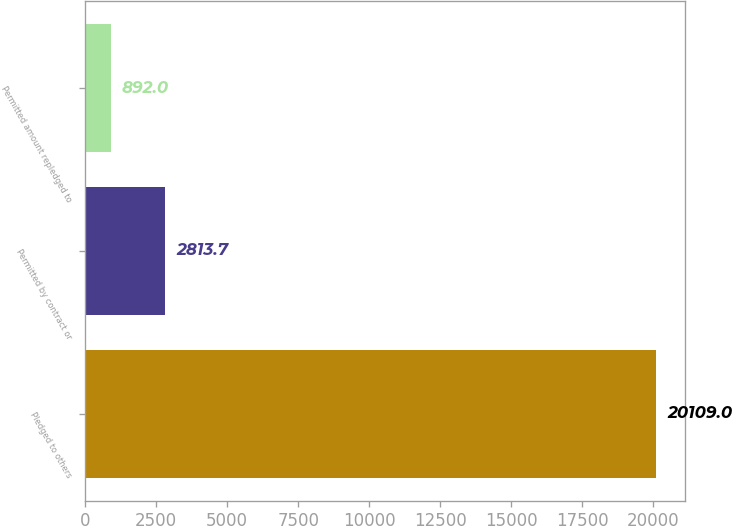Convert chart to OTSL. <chart><loc_0><loc_0><loc_500><loc_500><bar_chart><fcel>Pledged to others<fcel>Permitted by contract or<fcel>Permitted amount repledged to<nl><fcel>20109<fcel>2813.7<fcel>892<nl></chart> 